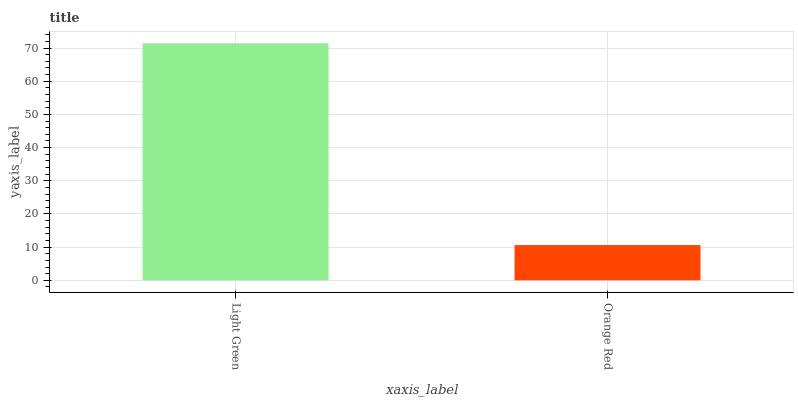Is Orange Red the maximum?
Answer yes or no. No. Is Light Green greater than Orange Red?
Answer yes or no. Yes. Is Orange Red less than Light Green?
Answer yes or no. Yes. Is Orange Red greater than Light Green?
Answer yes or no. No. Is Light Green less than Orange Red?
Answer yes or no. No. Is Light Green the high median?
Answer yes or no. Yes. Is Orange Red the low median?
Answer yes or no. Yes. Is Orange Red the high median?
Answer yes or no. No. Is Light Green the low median?
Answer yes or no. No. 